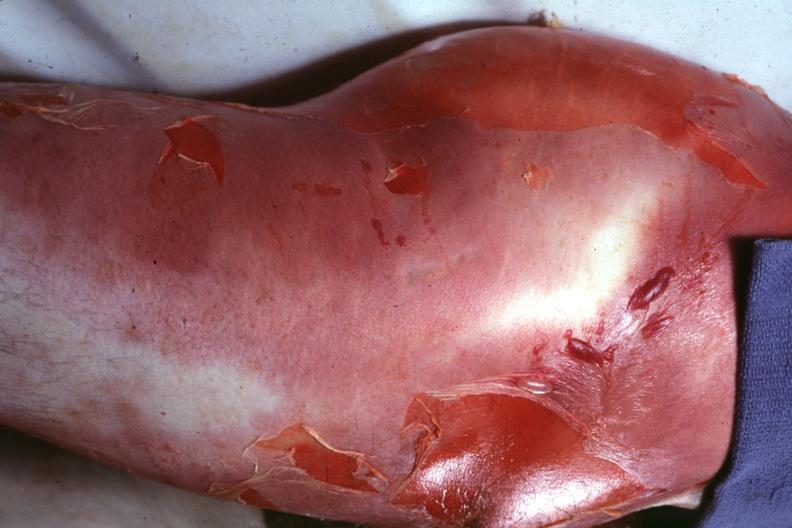how does this image show buttock and thigh?
Answer the question using a single word or phrase. With severe cellulitis desquamation caused by a clostridium 